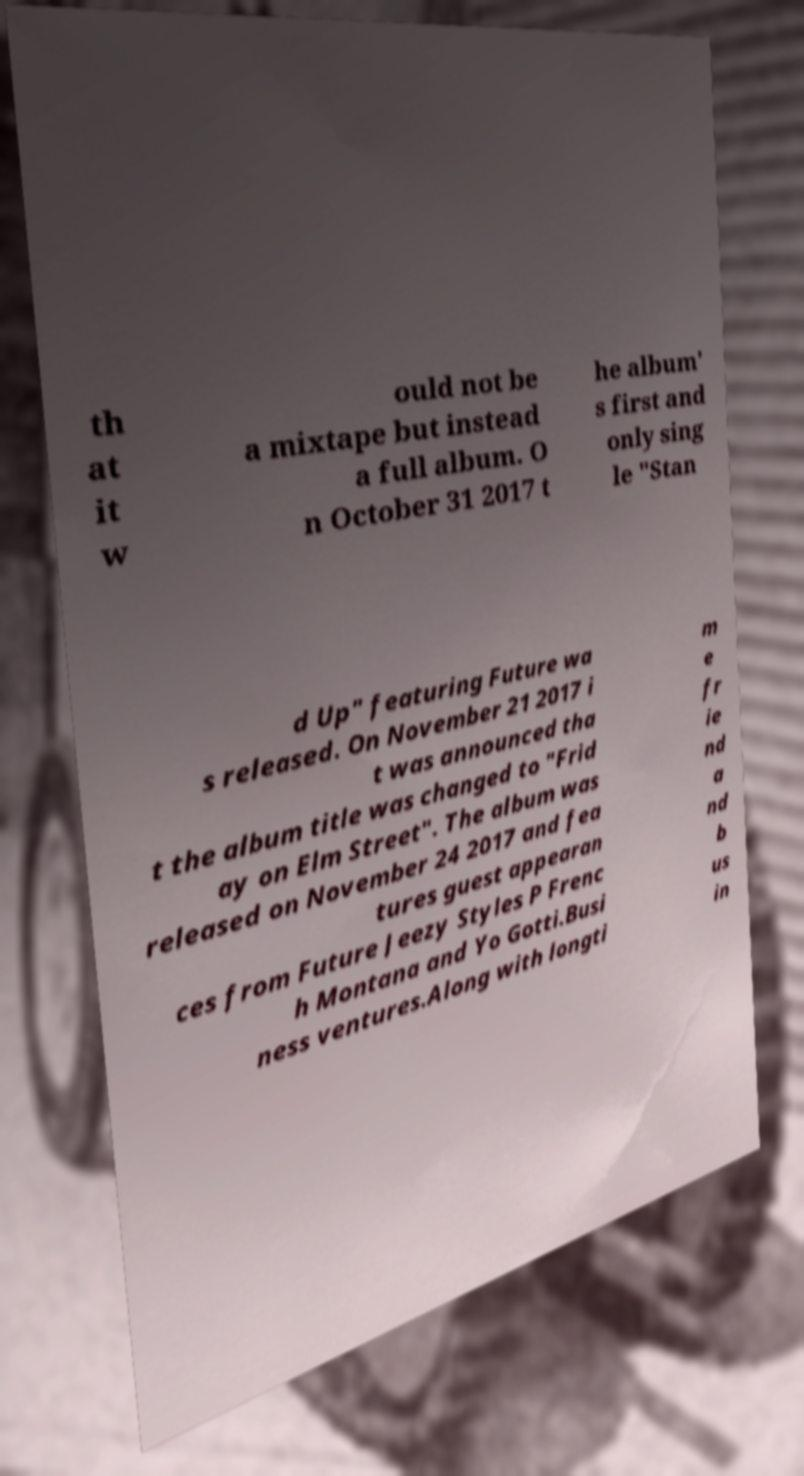Could you assist in decoding the text presented in this image and type it out clearly? th at it w ould not be a mixtape but instead a full album. O n October 31 2017 t he album' s first and only sing le "Stan d Up" featuring Future wa s released. On November 21 2017 i t was announced tha t the album title was changed to "Frid ay on Elm Street". The album was released on November 24 2017 and fea tures guest appearan ces from Future Jeezy Styles P Frenc h Montana and Yo Gotti.Busi ness ventures.Along with longti m e fr ie nd a nd b us in 